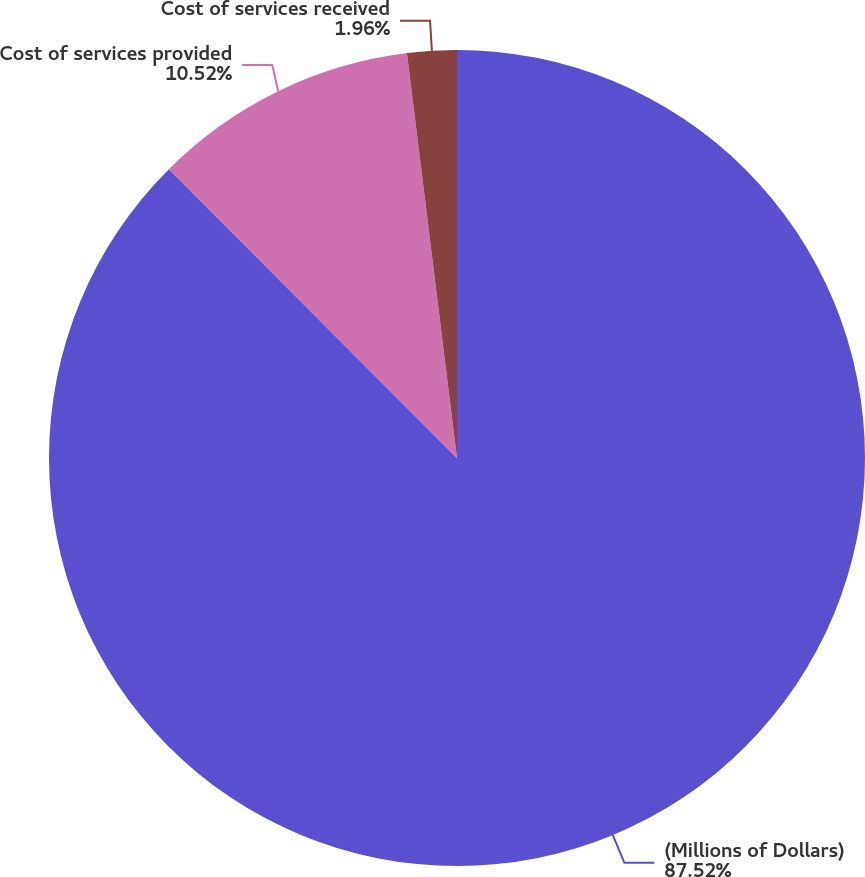<chart> <loc_0><loc_0><loc_500><loc_500><pie_chart><fcel>(Millions of Dollars)<fcel>Cost of services provided<fcel>Cost of services received<nl><fcel>87.52%<fcel>10.52%<fcel>1.96%<nl></chart> 